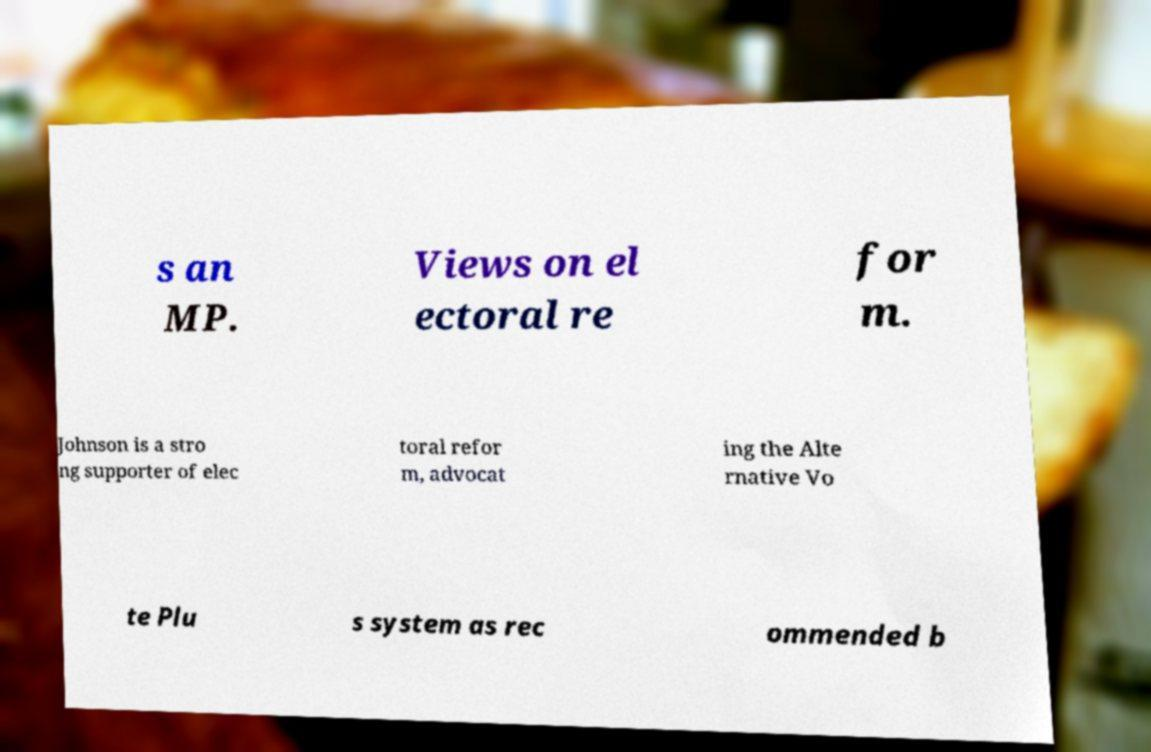Could you assist in decoding the text presented in this image and type it out clearly? s an MP. Views on el ectoral re for m. Johnson is a stro ng supporter of elec toral refor m, advocat ing the Alte rnative Vo te Plu s system as rec ommended b 